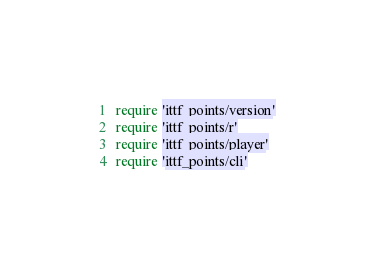Convert code to text. <code><loc_0><loc_0><loc_500><loc_500><_Ruby_>require 'ittf_points/version'
require 'ittf_points/r'
require 'ittf_points/player'
require 'ittf_points/cli'
</code> 